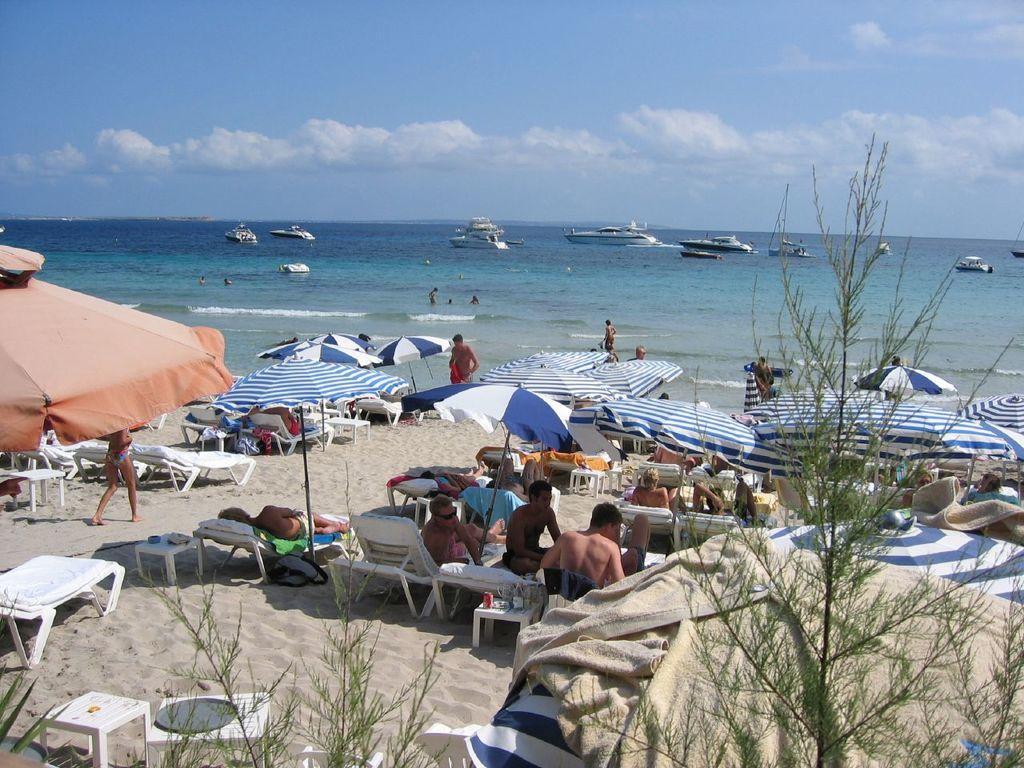In one or two sentences, can you explain what this image depicts? In the picture we can see a beach view with sand and on it we can see people sitting on the benches and on it we can see the umbrellas and far away from it, we can see water surface with some people are swimming and far away from them we can see some boats and in the background we can see the sky with clouds. 